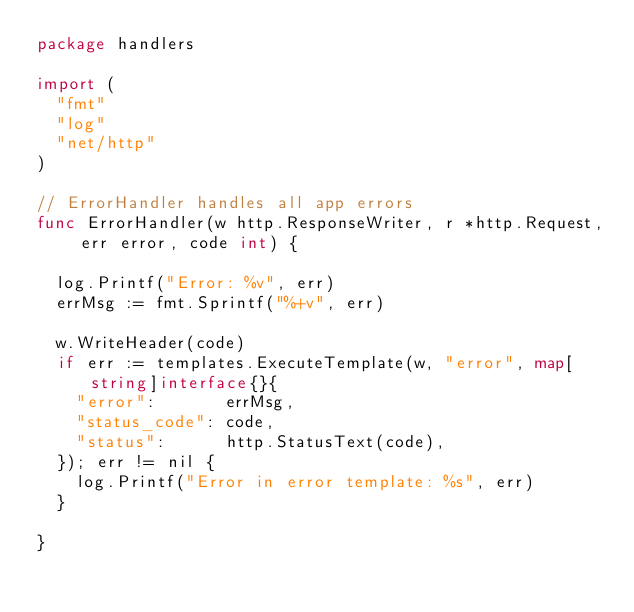<code> <loc_0><loc_0><loc_500><loc_500><_Go_>package handlers

import (
	"fmt"
	"log"
	"net/http"
)

// ErrorHandler handles all app errors
func ErrorHandler(w http.ResponseWriter, r *http.Request, err error, code int) {

	log.Printf("Error: %v", err)
	errMsg := fmt.Sprintf("%+v", err)

	w.WriteHeader(code)
	if err := templates.ExecuteTemplate(w, "error", map[string]interface{}{
		"error":       errMsg,
		"status_code": code,
		"status":      http.StatusText(code),
	}); err != nil {
		log.Printf("Error in error template: %s", err)
	}

}
</code> 